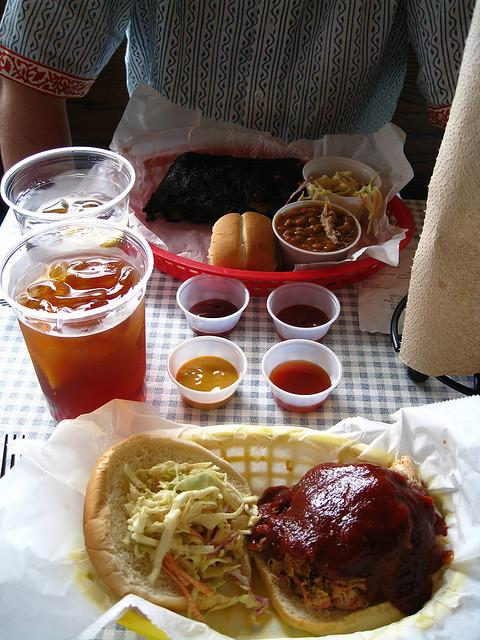What type of sandwich is being served? Please explain your reasoning. barbeque. The sandwich is bbq. 